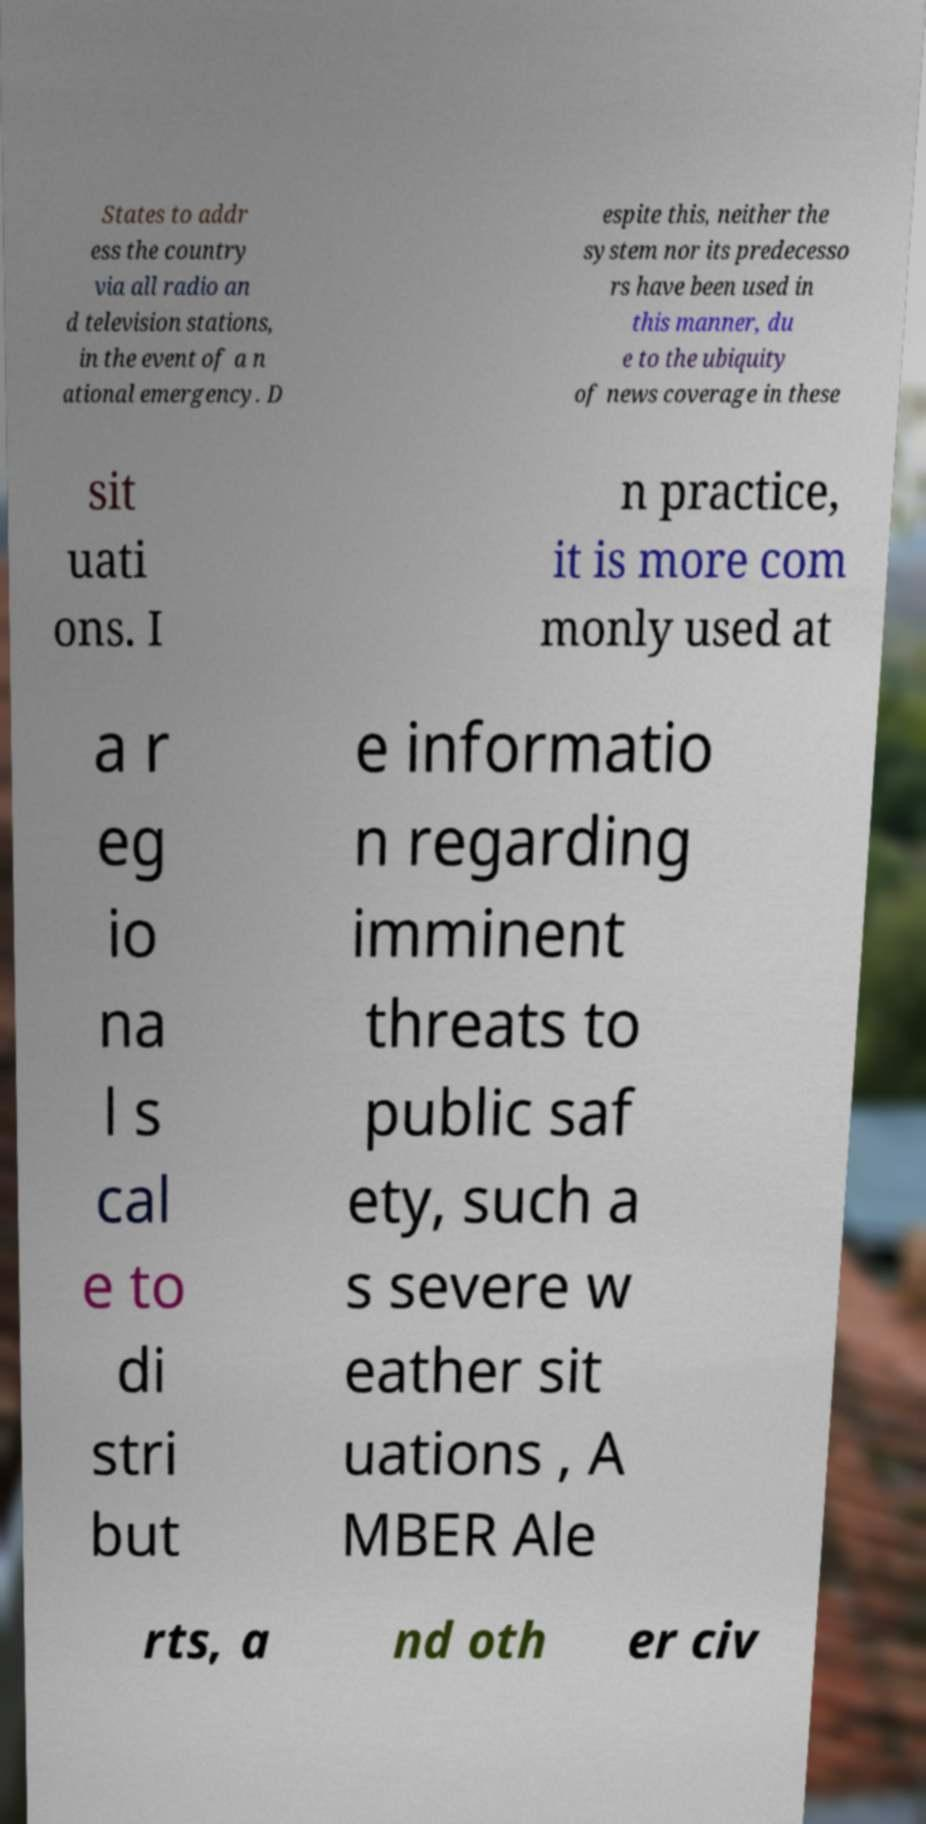There's text embedded in this image that I need extracted. Can you transcribe it verbatim? States to addr ess the country via all radio an d television stations, in the event of a n ational emergency. D espite this, neither the system nor its predecesso rs have been used in this manner, du e to the ubiquity of news coverage in these sit uati ons. I n practice, it is more com monly used at a r eg io na l s cal e to di stri but e informatio n regarding imminent threats to public saf ety, such a s severe w eather sit uations , A MBER Ale rts, a nd oth er civ 